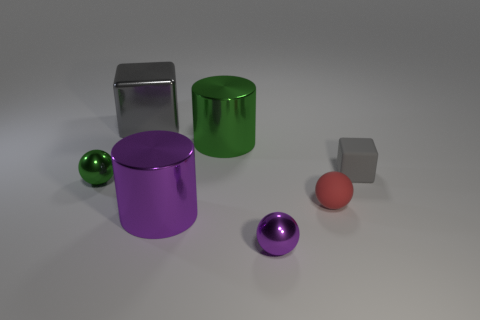How big is the purple metal thing on the left side of the large metallic cylinder that is behind the green shiny thing that is in front of the gray rubber cube?
Ensure brevity in your answer.  Large. How many other things are there of the same color as the big block?
Provide a succinct answer. 1. There is a red thing that is the same size as the purple shiny ball; what shape is it?
Provide a succinct answer. Sphere. How big is the cylinder behind the tiny green metallic object?
Provide a succinct answer. Large. Does the large cylinder that is in front of the green metallic ball have the same color as the shiny ball in front of the red ball?
Ensure brevity in your answer.  Yes. There is a small object behind the shiny ball behind the tiny metal sphere in front of the green sphere; what is it made of?
Provide a short and direct response. Rubber. Are there any gray cylinders of the same size as the gray metal object?
Provide a short and direct response. No. There is a gray cube that is the same size as the green sphere; what is its material?
Your answer should be compact. Rubber. What shape is the shiny object on the left side of the large gray metallic object?
Keep it short and to the point. Sphere. Is the material of the tiny ball in front of the purple shiny cylinder the same as the green thing that is on the left side of the large gray shiny object?
Offer a very short reply. Yes. 